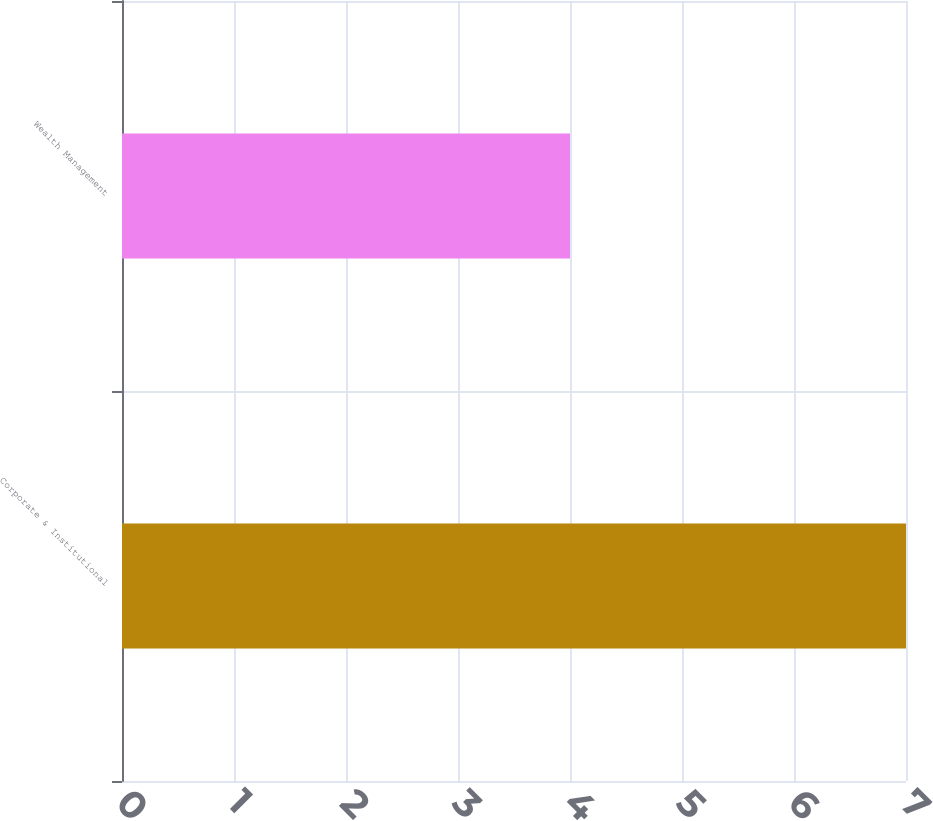Convert chart to OTSL. <chart><loc_0><loc_0><loc_500><loc_500><bar_chart><fcel>Corporate & Institutional<fcel>Wealth Management<nl><fcel>7<fcel>4<nl></chart> 